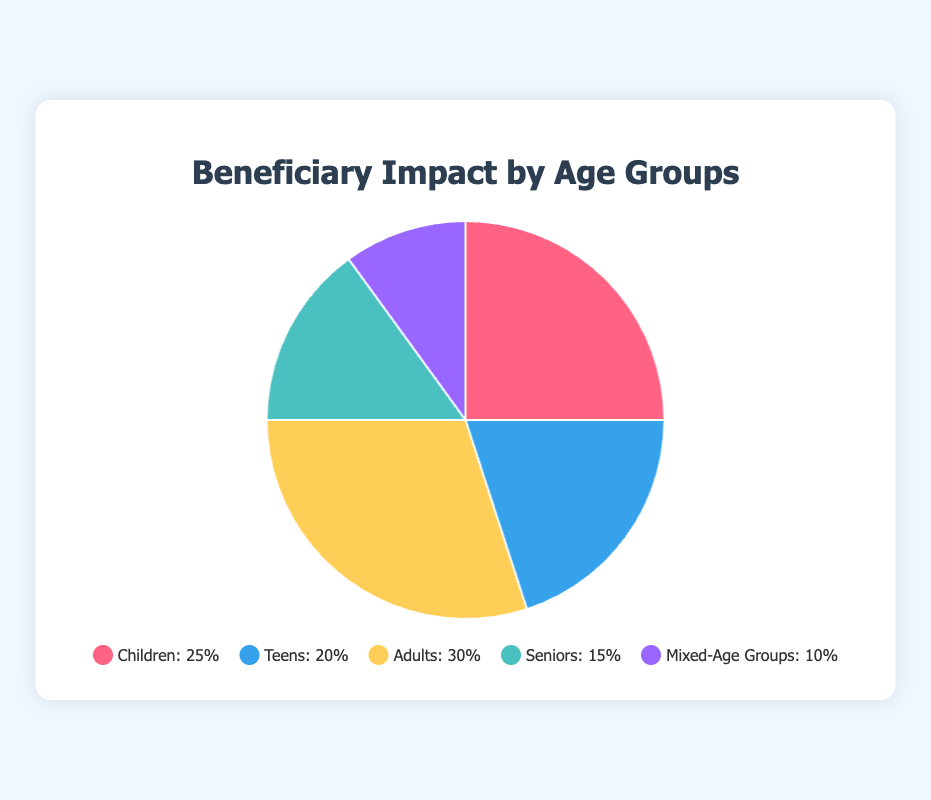Which age group has the highest percentage of beneficiaries? The pie chart shows the percentage for each age group. The group "Adults" has the segment with the highest percentage value of 30%.
Answer: Adults Which age group has the smallest percentage of beneficiaries? The pie chart indicates that the "Mixed-Age Groups" segment has the smallest percentage value of 10%.
Answer: Mixed-Age Groups What is the combined percentage of beneficiaries aged 12 and below and those aged 13-19? To find the combined percentage, add the percentages for "Children" and "Teens": 25% + 20% = 45%.
Answer: 45% How does the percentage of beneficiaries aged 60 years and above compare to those aged 0-12 years? Compare the values of "Seniors" (15%) and "Children" (25%). Since 15% is less than 25%, there are fewer seniors than children.
Answer: Seniors have a lower percentage than Children Which two age groups together make up half of the total beneficiaries? Summing 25% for "Children" and 25% out of 30% for "Adults" equals 50%. However, no group exactly sums to 50%. The closest is "Children" (25%) and "Teens" (20%) = 45%. Still, the pie chart doesn't show exactly 50%, so this indicates none together form half exactly.
Answer: None What is the difference in the percentage of beneficiaries between adults and teens? Subtract the percentage for "Teens" from "Adults": 30% - 20% = 10%.
Answer: 10% If you sum the percentages of beneficiaries for adults, teens, and children, what is the total? Add the percentages for "Adults" (30%), "Teens" (20%), and "Children" (25%): 30% + 20% + 25% = 75%.
Answer: 75% How does the segment color associated with adults differ from that of seniors? The segment for "Adults" is colored yellow, and the segment for "Seniors" is colored green.
Answer: Adults: yellow, Seniors: green 